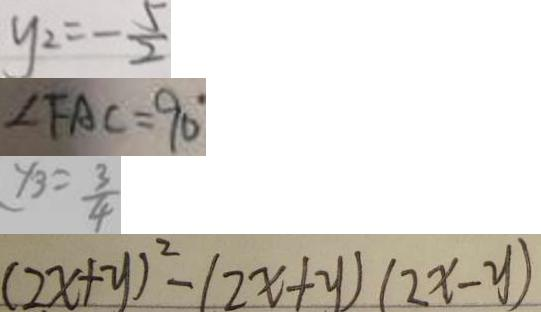Convert formula to latex. <formula><loc_0><loc_0><loc_500><loc_500>y _ { 2 } = - \frac { 5 } { 2 } 
 \angle F A C = 9 0 ^ { \circ } 
 y _ { 3 } = \frac { 3 } { 4 } 
 ( 2 x + y ) ^ { 2 } - ( 2 x + y ) ( 2 x - y )</formula> 